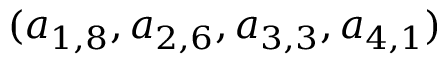Convert formula to latex. <formula><loc_0><loc_0><loc_500><loc_500>( a _ { 1 , 8 } , a _ { 2 , 6 } , a _ { 3 , 3 } , a _ { 4 , 1 } )</formula> 